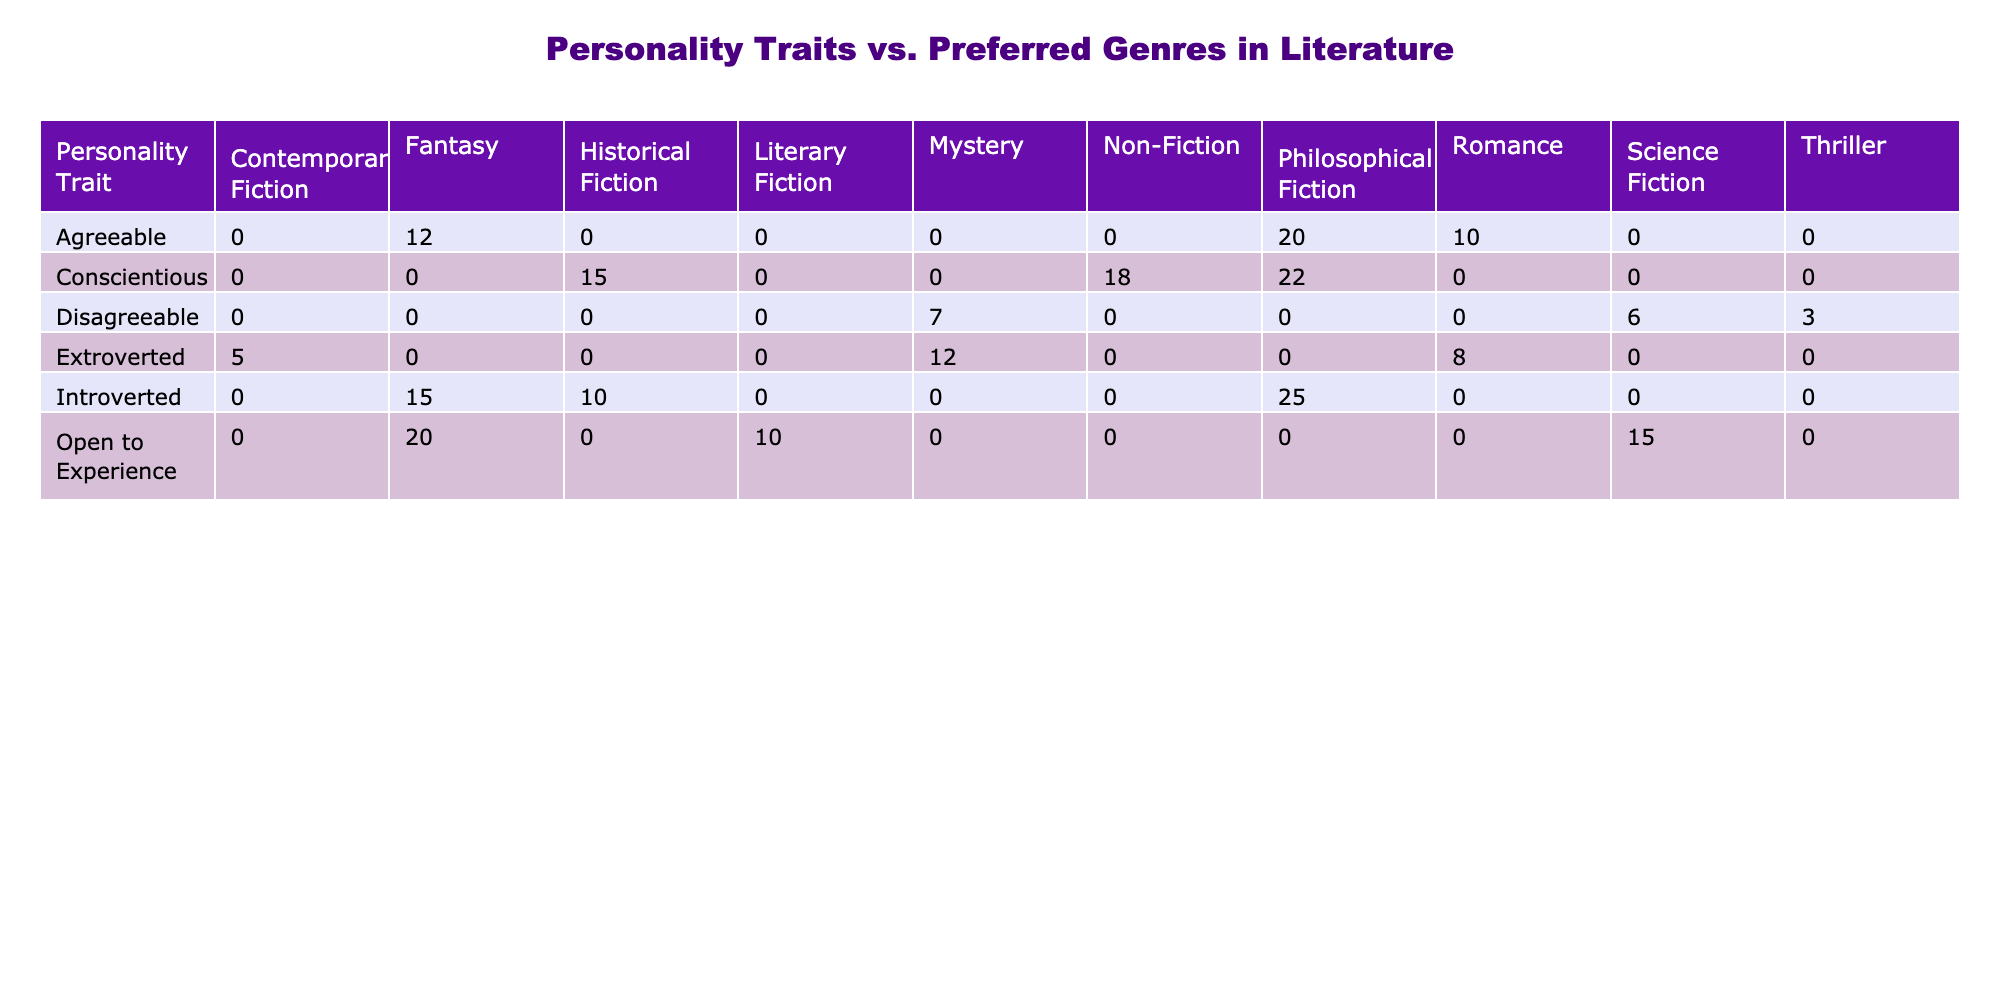What is the total count of introverted students who prefer philosophical fiction? There are 25 introverted students who prefer philosophical fiction according to the table.
Answer: 25 Which preferred genre is most popular among agreeable students? Agreeable students prefer philosophical fiction the most, with a count of 20, compared to 12 for fantasy and 10 for romance.
Answer: Philosophical Fiction How many extroverted students prefer contemporary fiction? The table shows that only 5 extroverted students prefer contemporary fiction.
Answer: 5 What is the sum of counts for all personality traits that prefer science fiction? The counts for disagreeable students is 6 and for open to experience is 15; thus, the total is 6 + 15 = 21.
Answer: 21 Is it true that the number of conscientious students who prefer non-fiction is greater than those who prefer historical fiction? The count for conscientious students who prefer non-fiction is 18, while for historical fiction, it is 15. Therefore, it is true.
Answer: Yes What is the average count of students who prefer fantasy among all personality traits? Adding the counts for fantasy: introverted (15), agreeable (12), open to experience (20), and extroverted (none) gives 15 + 12 + 20 = 47. There are 3 data points, so the average is 47/3 = 15.67.
Answer: 15.67 How does the total count of disagreeable students compare to the total count of introverted students? The total count of disagreeable students is 7 + 3 + 6 = 16; the total for introverted students is 25 + 15 + 10 = 50. Since 16 is less than 50, the disagreeable count is lower than the introverted count.
Answer: Disagreeable count is lower Which genre do open to experience students prefer the least? Open to experience students prefer literary fiction the least, with a count of 10, compared to 20 for fantasy and 15 for science fiction.
Answer: Literary Fiction What is the difference between the counts of extroverted students who prefer romance and those who prefer mystery? The count of extroverted students who prefer romance is 8, while for mystery it is 12. Thus, the difference is 12 - 8 = 4.
Answer: 4 